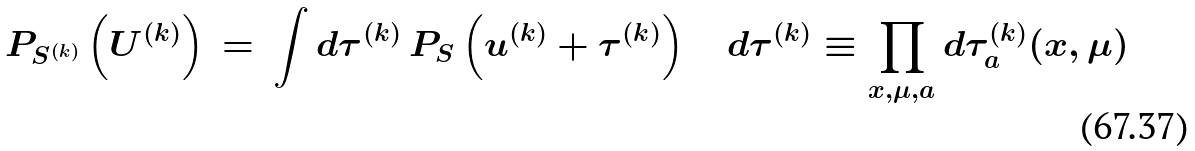Convert formula to latex. <formula><loc_0><loc_0><loc_500><loc_500>P _ { S ^ { ( k ) } } \left ( U ^ { ( k ) } \right ) \, = \, \int d \tau ^ { ( k ) } \, P _ { S } \left ( u ^ { ( k ) } + \tau ^ { ( k ) } \right ) \quad d \tau ^ { ( k ) } \equiv \prod _ { x , \mu , a } d \tau ^ { ( k ) } _ { a } ( x , \mu )</formula> 